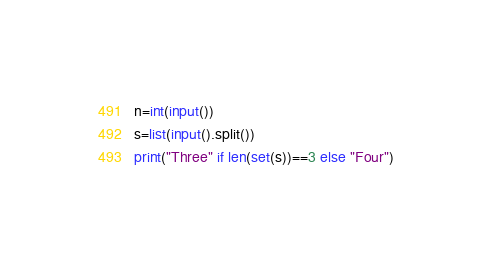<code> <loc_0><loc_0><loc_500><loc_500><_Python_>n=int(input())
s=list(input().split())
print("Three" if len(set(s))==3 else "Four")</code> 